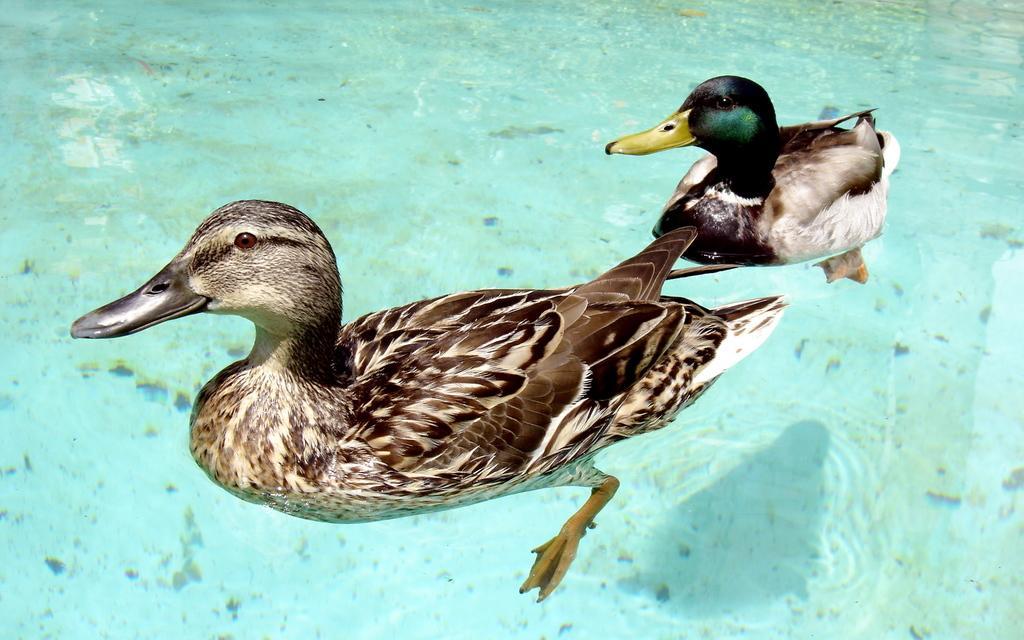Can you describe this image briefly? In this image I can see two birds in brown,white,black color. I can see the water. 